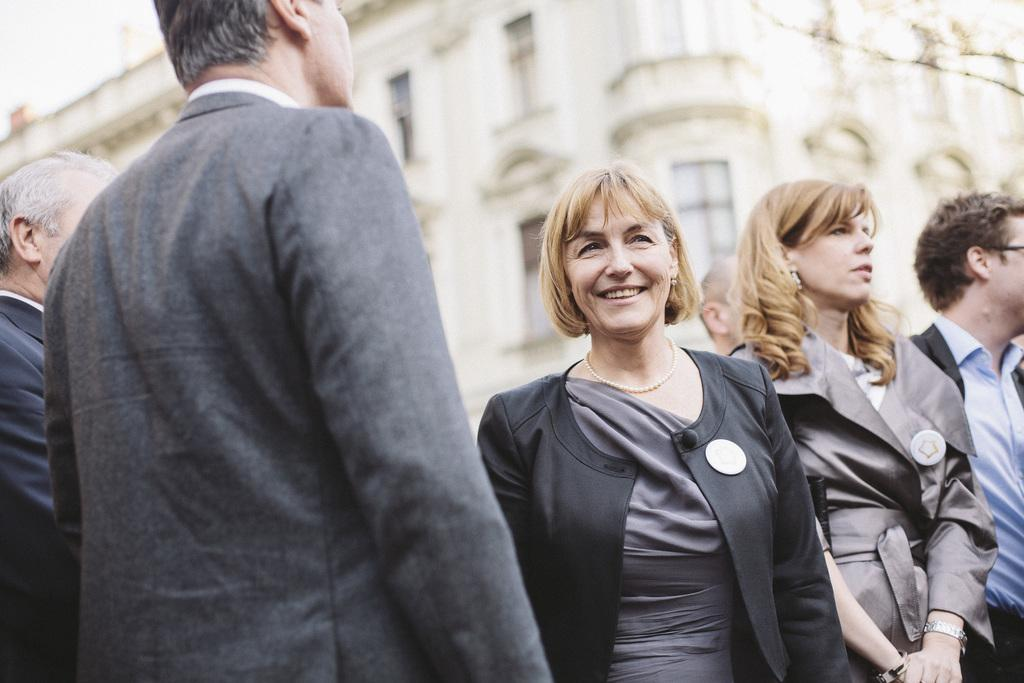What are the people in the image doing? The persons in the image are standing on the road. What can be seen in the background of the image? There is a building in the background of the image. What type of berry is being used to construct the building in the image? There is no mention of berries in the image, and the building is not constructed from berries. 